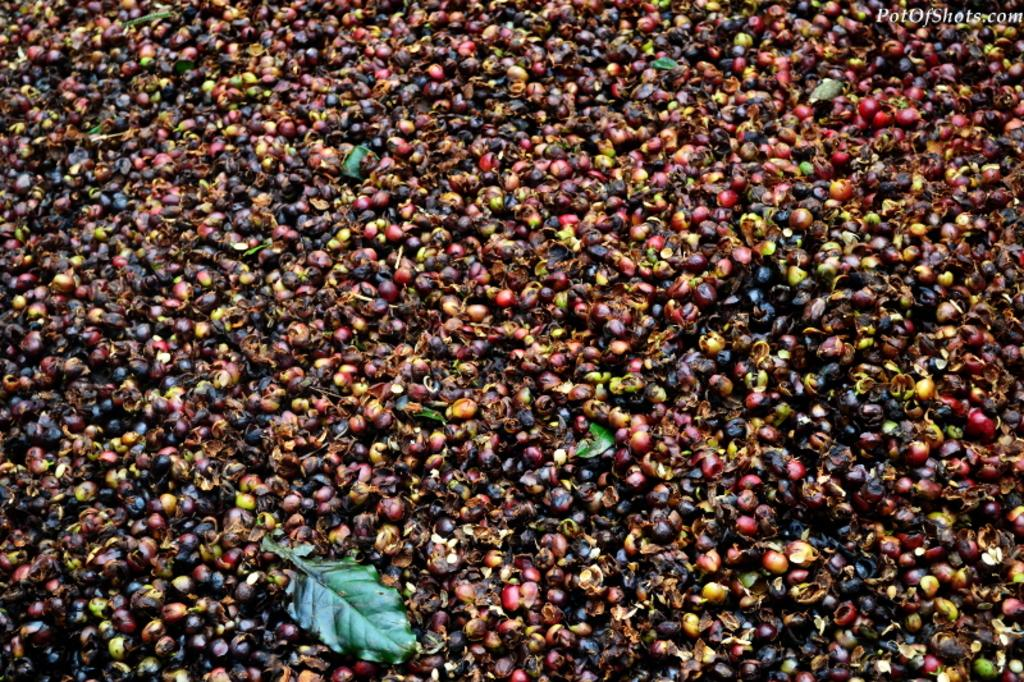What type of vegetation is present in the image? There are green leaves in the image. What else can be seen in the image besides the leaves? There are seeds visible in the image. Is there any text present in the image? Yes, there is text visible in the top right corner of the image. What type of cave can be seen in the image? There is no cave present in the image. What shape is the sneeze in the image? There is no sneeze present in the image. 